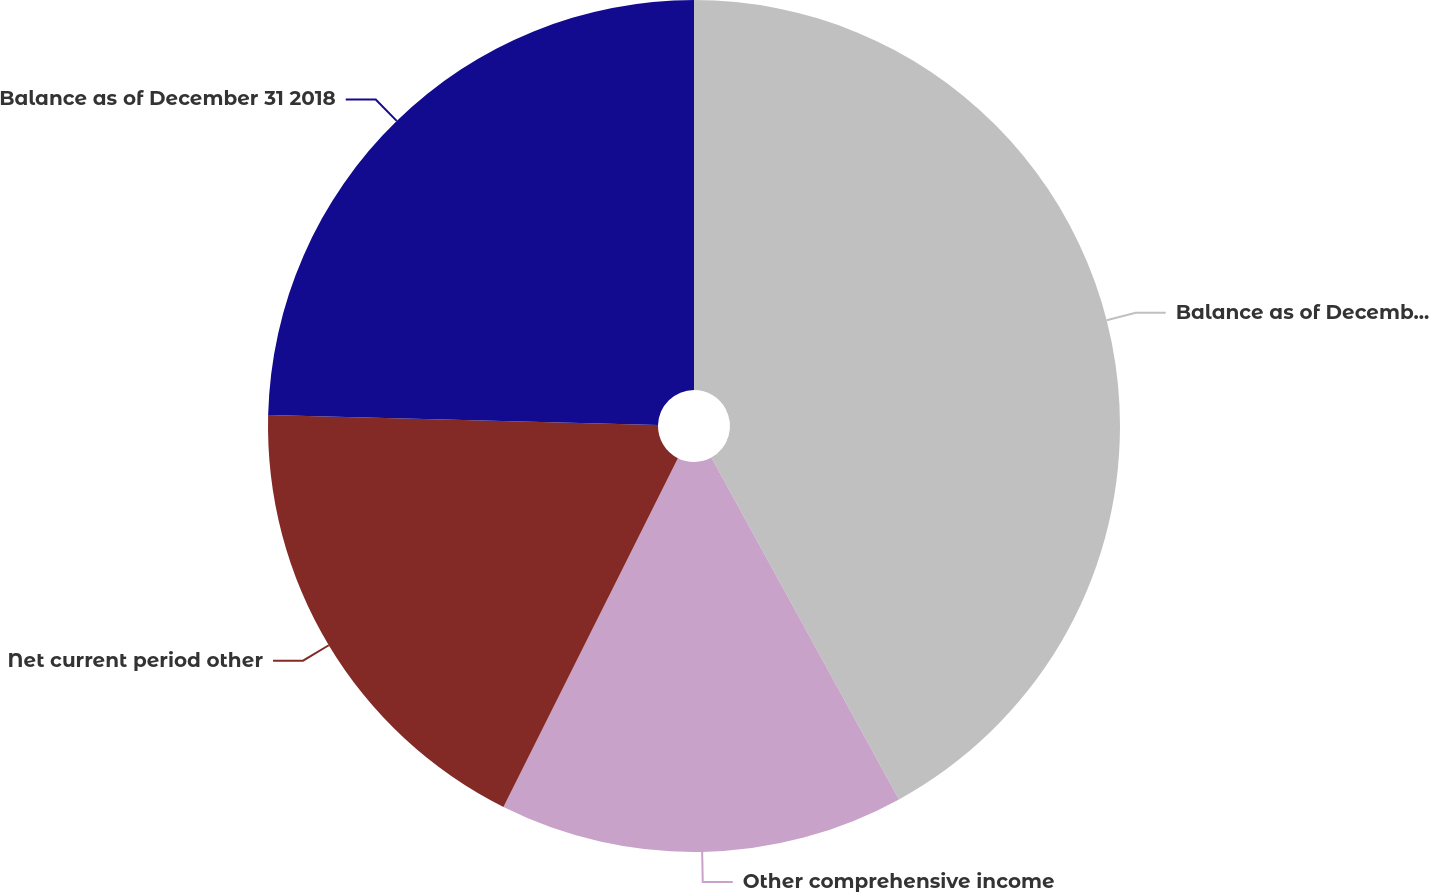Convert chart. <chart><loc_0><loc_0><loc_500><loc_500><pie_chart><fcel>Balance as of December 31 2017<fcel>Other comprehensive income<fcel>Net current period other<fcel>Balance as of December 31 2018<nl><fcel>42.01%<fcel>15.37%<fcel>18.03%<fcel>24.59%<nl></chart> 